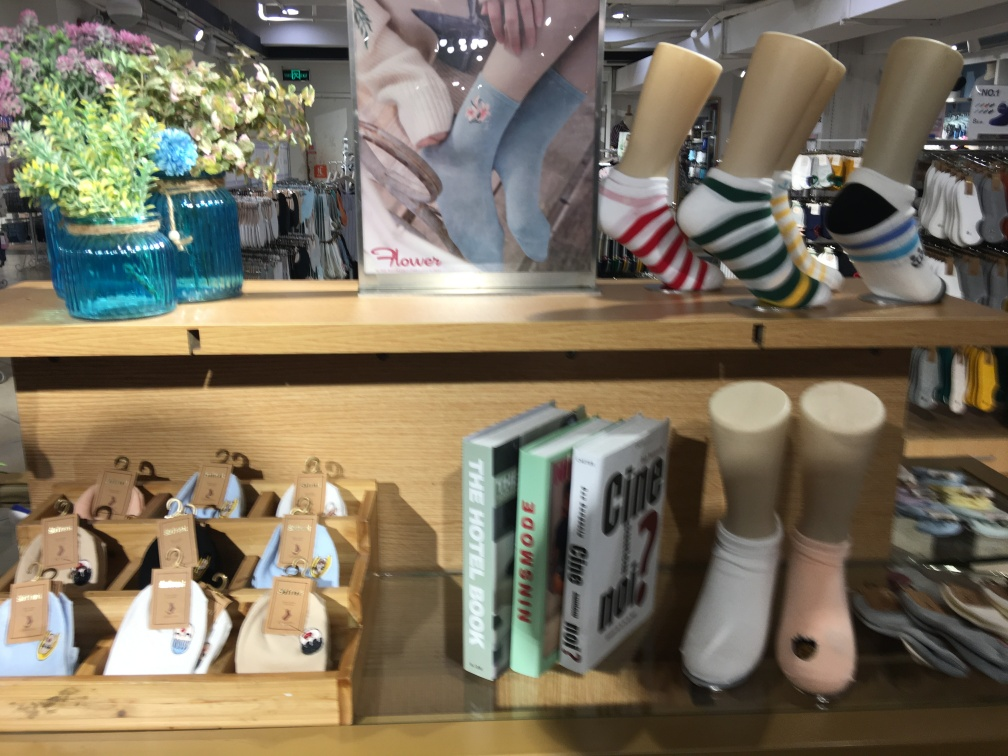Can you tell me what items are on display here? Certainly! The image shows a variety of items on display on a wooden shelf in a store. There's a clear blue glass vase with colorful flowers on the left, some books with titles related to traveling and city guides in the center, and to the right, there are display models showcasing different patterned socks. Are these items related in any way, or is there a theme to this display? The items seem to be loosely related by the theme of casual lifestyle and travel. The flowers add an aesthetic touch, the books suggest travel and exploration, and the patterned socks imply a casual, comfortable fashion choice, perhaps for someone who enjoys walking or exploring cities. 